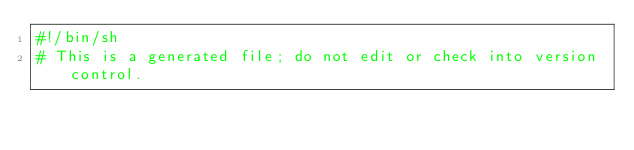<code> <loc_0><loc_0><loc_500><loc_500><_Bash_>#!/bin/sh
# This is a generated file; do not edit or check into version control.</code> 